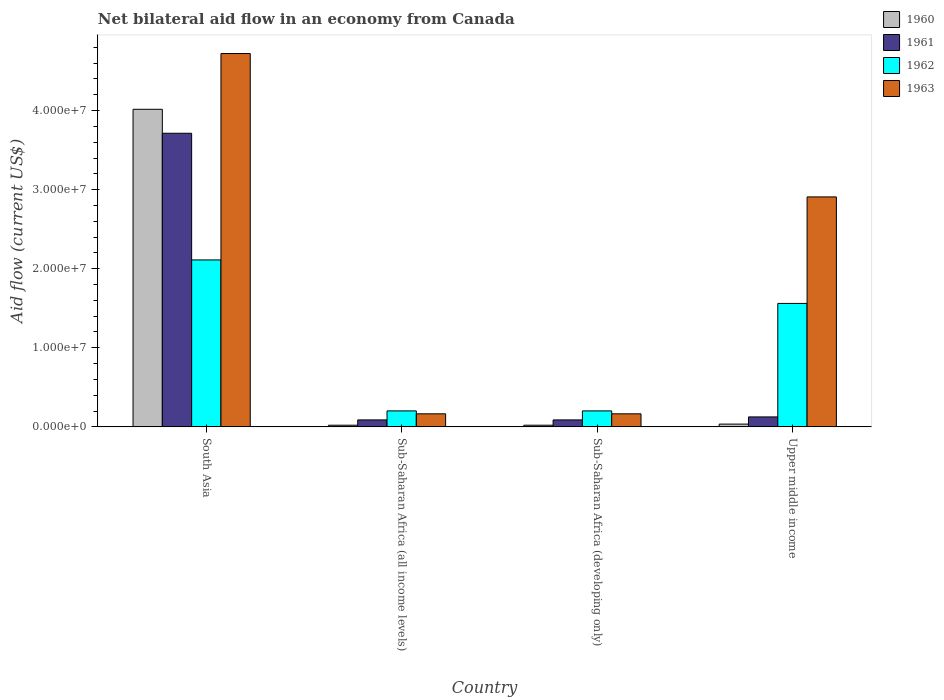How many different coloured bars are there?
Your answer should be very brief. 4. How many groups of bars are there?
Keep it short and to the point. 4. Are the number of bars on each tick of the X-axis equal?
Provide a short and direct response. Yes. How many bars are there on the 2nd tick from the right?
Provide a succinct answer. 4. What is the label of the 1st group of bars from the left?
Provide a succinct answer. South Asia. What is the net bilateral aid flow in 1962 in South Asia?
Your response must be concise. 2.11e+07. Across all countries, what is the maximum net bilateral aid flow in 1961?
Give a very brief answer. 3.71e+07. Across all countries, what is the minimum net bilateral aid flow in 1961?
Make the answer very short. 8.80e+05. In which country was the net bilateral aid flow in 1960 maximum?
Make the answer very short. South Asia. In which country was the net bilateral aid flow in 1962 minimum?
Offer a terse response. Sub-Saharan Africa (all income levels). What is the total net bilateral aid flow in 1963 in the graph?
Your answer should be very brief. 7.96e+07. What is the difference between the net bilateral aid flow in 1963 in Sub-Saharan Africa (developing only) and that in Upper middle income?
Provide a succinct answer. -2.74e+07. What is the difference between the net bilateral aid flow in 1961 in Sub-Saharan Africa (all income levels) and the net bilateral aid flow in 1962 in Sub-Saharan Africa (developing only)?
Provide a succinct answer. -1.14e+06. What is the average net bilateral aid flow in 1961 per country?
Make the answer very short. 1.00e+07. What is the difference between the net bilateral aid flow of/in 1963 and net bilateral aid flow of/in 1962 in Sub-Saharan Africa (developing only)?
Make the answer very short. -3.70e+05. What is the ratio of the net bilateral aid flow in 1963 in South Asia to that in Upper middle income?
Your answer should be compact. 1.62. Is the difference between the net bilateral aid flow in 1963 in Sub-Saharan Africa (developing only) and Upper middle income greater than the difference between the net bilateral aid flow in 1962 in Sub-Saharan Africa (developing only) and Upper middle income?
Offer a terse response. No. What is the difference between the highest and the second highest net bilateral aid flow in 1963?
Your answer should be very brief. 4.56e+07. What is the difference between the highest and the lowest net bilateral aid flow in 1963?
Provide a short and direct response. 4.56e+07. Is it the case that in every country, the sum of the net bilateral aid flow in 1962 and net bilateral aid flow in 1961 is greater than the sum of net bilateral aid flow in 1960 and net bilateral aid flow in 1963?
Make the answer very short. No. What does the 3rd bar from the left in South Asia represents?
Your answer should be very brief. 1962. What does the 4th bar from the right in Sub-Saharan Africa (all income levels) represents?
Your answer should be compact. 1960. Is it the case that in every country, the sum of the net bilateral aid flow in 1962 and net bilateral aid flow in 1963 is greater than the net bilateral aid flow in 1960?
Make the answer very short. Yes. How many bars are there?
Provide a succinct answer. 16. How many countries are there in the graph?
Your answer should be very brief. 4. What is the difference between two consecutive major ticks on the Y-axis?
Your response must be concise. 1.00e+07. Are the values on the major ticks of Y-axis written in scientific E-notation?
Your answer should be compact. Yes. Does the graph contain any zero values?
Offer a terse response. No. How are the legend labels stacked?
Ensure brevity in your answer.  Vertical. What is the title of the graph?
Your response must be concise. Net bilateral aid flow in an economy from Canada. Does "1978" appear as one of the legend labels in the graph?
Give a very brief answer. No. What is the label or title of the X-axis?
Provide a short and direct response. Country. What is the label or title of the Y-axis?
Give a very brief answer. Aid flow (current US$). What is the Aid flow (current US$) of 1960 in South Asia?
Your answer should be compact. 4.02e+07. What is the Aid flow (current US$) in 1961 in South Asia?
Provide a succinct answer. 3.71e+07. What is the Aid flow (current US$) in 1962 in South Asia?
Provide a short and direct response. 2.11e+07. What is the Aid flow (current US$) in 1963 in South Asia?
Ensure brevity in your answer.  4.72e+07. What is the Aid flow (current US$) in 1961 in Sub-Saharan Africa (all income levels)?
Make the answer very short. 8.80e+05. What is the Aid flow (current US$) in 1962 in Sub-Saharan Africa (all income levels)?
Your answer should be very brief. 2.02e+06. What is the Aid flow (current US$) in 1963 in Sub-Saharan Africa (all income levels)?
Provide a short and direct response. 1.65e+06. What is the Aid flow (current US$) in 1960 in Sub-Saharan Africa (developing only)?
Your answer should be very brief. 2.10e+05. What is the Aid flow (current US$) of 1961 in Sub-Saharan Africa (developing only)?
Offer a very short reply. 8.80e+05. What is the Aid flow (current US$) of 1962 in Sub-Saharan Africa (developing only)?
Your answer should be compact. 2.02e+06. What is the Aid flow (current US$) of 1963 in Sub-Saharan Africa (developing only)?
Offer a very short reply. 1.65e+06. What is the Aid flow (current US$) of 1960 in Upper middle income?
Your answer should be compact. 3.50e+05. What is the Aid flow (current US$) of 1961 in Upper middle income?
Make the answer very short. 1.26e+06. What is the Aid flow (current US$) of 1962 in Upper middle income?
Your response must be concise. 1.56e+07. What is the Aid flow (current US$) in 1963 in Upper middle income?
Your response must be concise. 2.91e+07. Across all countries, what is the maximum Aid flow (current US$) of 1960?
Make the answer very short. 4.02e+07. Across all countries, what is the maximum Aid flow (current US$) of 1961?
Keep it short and to the point. 3.71e+07. Across all countries, what is the maximum Aid flow (current US$) in 1962?
Keep it short and to the point. 2.11e+07. Across all countries, what is the maximum Aid flow (current US$) of 1963?
Offer a terse response. 4.72e+07. Across all countries, what is the minimum Aid flow (current US$) of 1961?
Your response must be concise. 8.80e+05. Across all countries, what is the minimum Aid flow (current US$) in 1962?
Your answer should be very brief. 2.02e+06. Across all countries, what is the minimum Aid flow (current US$) in 1963?
Offer a very short reply. 1.65e+06. What is the total Aid flow (current US$) in 1960 in the graph?
Make the answer very short. 4.09e+07. What is the total Aid flow (current US$) of 1961 in the graph?
Ensure brevity in your answer.  4.02e+07. What is the total Aid flow (current US$) of 1962 in the graph?
Keep it short and to the point. 4.08e+07. What is the total Aid flow (current US$) of 1963 in the graph?
Your response must be concise. 7.96e+07. What is the difference between the Aid flow (current US$) in 1960 in South Asia and that in Sub-Saharan Africa (all income levels)?
Your response must be concise. 4.00e+07. What is the difference between the Aid flow (current US$) of 1961 in South Asia and that in Sub-Saharan Africa (all income levels)?
Your answer should be very brief. 3.62e+07. What is the difference between the Aid flow (current US$) of 1962 in South Asia and that in Sub-Saharan Africa (all income levels)?
Your response must be concise. 1.91e+07. What is the difference between the Aid flow (current US$) in 1963 in South Asia and that in Sub-Saharan Africa (all income levels)?
Your answer should be very brief. 4.56e+07. What is the difference between the Aid flow (current US$) of 1960 in South Asia and that in Sub-Saharan Africa (developing only)?
Offer a terse response. 4.00e+07. What is the difference between the Aid flow (current US$) of 1961 in South Asia and that in Sub-Saharan Africa (developing only)?
Keep it short and to the point. 3.62e+07. What is the difference between the Aid flow (current US$) in 1962 in South Asia and that in Sub-Saharan Africa (developing only)?
Offer a terse response. 1.91e+07. What is the difference between the Aid flow (current US$) of 1963 in South Asia and that in Sub-Saharan Africa (developing only)?
Your answer should be very brief. 4.56e+07. What is the difference between the Aid flow (current US$) in 1960 in South Asia and that in Upper middle income?
Make the answer very short. 3.98e+07. What is the difference between the Aid flow (current US$) in 1961 in South Asia and that in Upper middle income?
Provide a short and direct response. 3.59e+07. What is the difference between the Aid flow (current US$) of 1962 in South Asia and that in Upper middle income?
Give a very brief answer. 5.50e+06. What is the difference between the Aid flow (current US$) of 1963 in South Asia and that in Upper middle income?
Make the answer very short. 1.81e+07. What is the difference between the Aid flow (current US$) of 1962 in Sub-Saharan Africa (all income levels) and that in Sub-Saharan Africa (developing only)?
Keep it short and to the point. 0. What is the difference between the Aid flow (current US$) in 1963 in Sub-Saharan Africa (all income levels) and that in Sub-Saharan Africa (developing only)?
Your answer should be very brief. 0. What is the difference between the Aid flow (current US$) of 1961 in Sub-Saharan Africa (all income levels) and that in Upper middle income?
Offer a very short reply. -3.80e+05. What is the difference between the Aid flow (current US$) of 1962 in Sub-Saharan Africa (all income levels) and that in Upper middle income?
Offer a terse response. -1.36e+07. What is the difference between the Aid flow (current US$) in 1963 in Sub-Saharan Africa (all income levels) and that in Upper middle income?
Keep it short and to the point. -2.74e+07. What is the difference between the Aid flow (current US$) in 1961 in Sub-Saharan Africa (developing only) and that in Upper middle income?
Keep it short and to the point. -3.80e+05. What is the difference between the Aid flow (current US$) in 1962 in Sub-Saharan Africa (developing only) and that in Upper middle income?
Make the answer very short. -1.36e+07. What is the difference between the Aid flow (current US$) in 1963 in Sub-Saharan Africa (developing only) and that in Upper middle income?
Ensure brevity in your answer.  -2.74e+07. What is the difference between the Aid flow (current US$) in 1960 in South Asia and the Aid flow (current US$) in 1961 in Sub-Saharan Africa (all income levels)?
Provide a short and direct response. 3.93e+07. What is the difference between the Aid flow (current US$) of 1960 in South Asia and the Aid flow (current US$) of 1962 in Sub-Saharan Africa (all income levels)?
Offer a very short reply. 3.81e+07. What is the difference between the Aid flow (current US$) of 1960 in South Asia and the Aid flow (current US$) of 1963 in Sub-Saharan Africa (all income levels)?
Provide a short and direct response. 3.85e+07. What is the difference between the Aid flow (current US$) in 1961 in South Asia and the Aid flow (current US$) in 1962 in Sub-Saharan Africa (all income levels)?
Your answer should be compact. 3.51e+07. What is the difference between the Aid flow (current US$) of 1961 in South Asia and the Aid flow (current US$) of 1963 in Sub-Saharan Africa (all income levels)?
Provide a succinct answer. 3.55e+07. What is the difference between the Aid flow (current US$) in 1962 in South Asia and the Aid flow (current US$) in 1963 in Sub-Saharan Africa (all income levels)?
Provide a succinct answer. 1.95e+07. What is the difference between the Aid flow (current US$) in 1960 in South Asia and the Aid flow (current US$) in 1961 in Sub-Saharan Africa (developing only)?
Your answer should be very brief. 3.93e+07. What is the difference between the Aid flow (current US$) in 1960 in South Asia and the Aid flow (current US$) in 1962 in Sub-Saharan Africa (developing only)?
Ensure brevity in your answer.  3.81e+07. What is the difference between the Aid flow (current US$) of 1960 in South Asia and the Aid flow (current US$) of 1963 in Sub-Saharan Africa (developing only)?
Your answer should be compact. 3.85e+07. What is the difference between the Aid flow (current US$) of 1961 in South Asia and the Aid flow (current US$) of 1962 in Sub-Saharan Africa (developing only)?
Make the answer very short. 3.51e+07. What is the difference between the Aid flow (current US$) of 1961 in South Asia and the Aid flow (current US$) of 1963 in Sub-Saharan Africa (developing only)?
Your response must be concise. 3.55e+07. What is the difference between the Aid flow (current US$) of 1962 in South Asia and the Aid flow (current US$) of 1963 in Sub-Saharan Africa (developing only)?
Keep it short and to the point. 1.95e+07. What is the difference between the Aid flow (current US$) of 1960 in South Asia and the Aid flow (current US$) of 1961 in Upper middle income?
Your answer should be very brief. 3.89e+07. What is the difference between the Aid flow (current US$) in 1960 in South Asia and the Aid flow (current US$) in 1962 in Upper middle income?
Offer a terse response. 2.46e+07. What is the difference between the Aid flow (current US$) in 1960 in South Asia and the Aid flow (current US$) in 1963 in Upper middle income?
Provide a succinct answer. 1.11e+07. What is the difference between the Aid flow (current US$) of 1961 in South Asia and the Aid flow (current US$) of 1962 in Upper middle income?
Make the answer very short. 2.15e+07. What is the difference between the Aid flow (current US$) of 1961 in South Asia and the Aid flow (current US$) of 1963 in Upper middle income?
Give a very brief answer. 8.05e+06. What is the difference between the Aid flow (current US$) in 1962 in South Asia and the Aid flow (current US$) in 1963 in Upper middle income?
Your answer should be compact. -7.97e+06. What is the difference between the Aid flow (current US$) of 1960 in Sub-Saharan Africa (all income levels) and the Aid flow (current US$) of 1961 in Sub-Saharan Africa (developing only)?
Provide a succinct answer. -6.70e+05. What is the difference between the Aid flow (current US$) of 1960 in Sub-Saharan Africa (all income levels) and the Aid flow (current US$) of 1962 in Sub-Saharan Africa (developing only)?
Ensure brevity in your answer.  -1.81e+06. What is the difference between the Aid flow (current US$) of 1960 in Sub-Saharan Africa (all income levels) and the Aid flow (current US$) of 1963 in Sub-Saharan Africa (developing only)?
Your response must be concise. -1.44e+06. What is the difference between the Aid flow (current US$) of 1961 in Sub-Saharan Africa (all income levels) and the Aid flow (current US$) of 1962 in Sub-Saharan Africa (developing only)?
Your answer should be very brief. -1.14e+06. What is the difference between the Aid flow (current US$) in 1961 in Sub-Saharan Africa (all income levels) and the Aid flow (current US$) in 1963 in Sub-Saharan Africa (developing only)?
Offer a terse response. -7.70e+05. What is the difference between the Aid flow (current US$) of 1962 in Sub-Saharan Africa (all income levels) and the Aid flow (current US$) of 1963 in Sub-Saharan Africa (developing only)?
Your answer should be very brief. 3.70e+05. What is the difference between the Aid flow (current US$) of 1960 in Sub-Saharan Africa (all income levels) and the Aid flow (current US$) of 1961 in Upper middle income?
Make the answer very short. -1.05e+06. What is the difference between the Aid flow (current US$) in 1960 in Sub-Saharan Africa (all income levels) and the Aid flow (current US$) in 1962 in Upper middle income?
Your response must be concise. -1.54e+07. What is the difference between the Aid flow (current US$) of 1960 in Sub-Saharan Africa (all income levels) and the Aid flow (current US$) of 1963 in Upper middle income?
Offer a very short reply. -2.89e+07. What is the difference between the Aid flow (current US$) in 1961 in Sub-Saharan Africa (all income levels) and the Aid flow (current US$) in 1962 in Upper middle income?
Keep it short and to the point. -1.47e+07. What is the difference between the Aid flow (current US$) in 1961 in Sub-Saharan Africa (all income levels) and the Aid flow (current US$) in 1963 in Upper middle income?
Offer a terse response. -2.82e+07. What is the difference between the Aid flow (current US$) in 1962 in Sub-Saharan Africa (all income levels) and the Aid flow (current US$) in 1963 in Upper middle income?
Offer a terse response. -2.71e+07. What is the difference between the Aid flow (current US$) in 1960 in Sub-Saharan Africa (developing only) and the Aid flow (current US$) in 1961 in Upper middle income?
Your answer should be very brief. -1.05e+06. What is the difference between the Aid flow (current US$) in 1960 in Sub-Saharan Africa (developing only) and the Aid flow (current US$) in 1962 in Upper middle income?
Make the answer very short. -1.54e+07. What is the difference between the Aid flow (current US$) in 1960 in Sub-Saharan Africa (developing only) and the Aid flow (current US$) in 1963 in Upper middle income?
Ensure brevity in your answer.  -2.89e+07. What is the difference between the Aid flow (current US$) of 1961 in Sub-Saharan Africa (developing only) and the Aid flow (current US$) of 1962 in Upper middle income?
Give a very brief answer. -1.47e+07. What is the difference between the Aid flow (current US$) of 1961 in Sub-Saharan Africa (developing only) and the Aid flow (current US$) of 1963 in Upper middle income?
Provide a succinct answer. -2.82e+07. What is the difference between the Aid flow (current US$) in 1962 in Sub-Saharan Africa (developing only) and the Aid flow (current US$) in 1963 in Upper middle income?
Ensure brevity in your answer.  -2.71e+07. What is the average Aid flow (current US$) of 1960 per country?
Offer a terse response. 1.02e+07. What is the average Aid flow (current US$) in 1961 per country?
Provide a short and direct response. 1.00e+07. What is the average Aid flow (current US$) in 1962 per country?
Keep it short and to the point. 1.02e+07. What is the average Aid flow (current US$) of 1963 per country?
Offer a terse response. 1.99e+07. What is the difference between the Aid flow (current US$) in 1960 and Aid flow (current US$) in 1961 in South Asia?
Keep it short and to the point. 3.03e+06. What is the difference between the Aid flow (current US$) of 1960 and Aid flow (current US$) of 1962 in South Asia?
Offer a terse response. 1.90e+07. What is the difference between the Aid flow (current US$) of 1960 and Aid flow (current US$) of 1963 in South Asia?
Give a very brief answer. -7.05e+06. What is the difference between the Aid flow (current US$) in 1961 and Aid flow (current US$) in 1962 in South Asia?
Your answer should be compact. 1.60e+07. What is the difference between the Aid flow (current US$) of 1961 and Aid flow (current US$) of 1963 in South Asia?
Provide a short and direct response. -1.01e+07. What is the difference between the Aid flow (current US$) in 1962 and Aid flow (current US$) in 1963 in South Asia?
Provide a succinct answer. -2.61e+07. What is the difference between the Aid flow (current US$) of 1960 and Aid flow (current US$) of 1961 in Sub-Saharan Africa (all income levels)?
Provide a succinct answer. -6.70e+05. What is the difference between the Aid flow (current US$) of 1960 and Aid flow (current US$) of 1962 in Sub-Saharan Africa (all income levels)?
Your answer should be compact. -1.81e+06. What is the difference between the Aid flow (current US$) of 1960 and Aid flow (current US$) of 1963 in Sub-Saharan Africa (all income levels)?
Your answer should be very brief. -1.44e+06. What is the difference between the Aid flow (current US$) of 1961 and Aid flow (current US$) of 1962 in Sub-Saharan Africa (all income levels)?
Offer a very short reply. -1.14e+06. What is the difference between the Aid flow (current US$) of 1961 and Aid flow (current US$) of 1963 in Sub-Saharan Africa (all income levels)?
Provide a short and direct response. -7.70e+05. What is the difference between the Aid flow (current US$) in 1960 and Aid flow (current US$) in 1961 in Sub-Saharan Africa (developing only)?
Give a very brief answer. -6.70e+05. What is the difference between the Aid flow (current US$) of 1960 and Aid flow (current US$) of 1962 in Sub-Saharan Africa (developing only)?
Your response must be concise. -1.81e+06. What is the difference between the Aid flow (current US$) in 1960 and Aid flow (current US$) in 1963 in Sub-Saharan Africa (developing only)?
Your response must be concise. -1.44e+06. What is the difference between the Aid flow (current US$) of 1961 and Aid flow (current US$) of 1962 in Sub-Saharan Africa (developing only)?
Keep it short and to the point. -1.14e+06. What is the difference between the Aid flow (current US$) in 1961 and Aid flow (current US$) in 1963 in Sub-Saharan Africa (developing only)?
Your answer should be very brief. -7.70e+05. What is the difference between the Aid flow (current US$) of 1960 and Aid flow (current US$) of 1961 in Upper middle income?
Your answer should be compact. -9.10e+05. What is the difference between the Aid flow (current US$) of 1960 and Aid flow (current US$) of 1962 in Upper middle income?
Your response must be concise. -1.53e+07. What is the difference between the Aid flow (current US$) of 1960 and Aid flow (current US$) of 1963 in Upper middle income?
Give a very brief answer. -2.87e+07. What is the difference between the Aid flow (current US$) of 1961 and Aid flow (current US$) of 1962 in Upper middle income?
Give a very brief answer. -1.44e+07. What is the difference between the Aid flow (current US$) of 1961 and Aid flow (current US$) of 1963 in Upper middle income?
Your answer should be very brief. -2.78e+07. What is the difference between the Aid flow (current US$) in 1962 and Aid flow (current US$) in 1963 in Upper middle income?
Provide a short and direct response. -1.35e+07. What is the ratio of the Aid flow (current US$) in 1960 in South Asia to that in Sub-Saharan Africa (all income levels)?
Ensure brevity in your answer.  191.24. What is the ratio of the Aid flow (current US$) of 1961 in South Asia to that in Sub-Saharan Africa (all income levels)?
Your answer should be compact. 42.19. What is the ratio of the Aid flow (current US$) of 1962 in South Asia to that in Sub-Saharan Africa (all income levels)?
Your answer should be compact. 10.45. What is the ratio of the Aid flow (current US$) of 1963 in South Asia to that in Sub-Saharan Africa (all income levels)?
Your answer should be very brief. 28.61. What is the ratio of the Aid flow (current US$) in 1960 in South Asia to that in Sub-Saharan Africa (developing only)?
Your response must be concise. 191.24. What is the ratio of the Aid flow (current US$) of 1961 in South Asia to that in Sub-Saharan Africa (developing only)?
Your answer should be compact. 42.19. What is the ratio of the Aid flow (current US$) in 1962 in South Asia to that in Sub-Saharan Africa (developing only)?
Make the answer very short. 10.45. What is the ratio of the Aid flow (current US$) in 1963 in South Asia to that in Sub-Saharan Africa (developing only)?
Your response must be concise. 28.61. What is the ratio of the Aid flow (current US$) in 1960 in South Asia to that in Upper middle income?
Your answer should be very brief. 114.74. What is the ratio of the Aid flow (current US$) of 1961 in South Asia to that in Upper middle income?
Give a very brief answer. 29.47. What is the ratio of the Aid flow (current US$) of 1962 in South Asia to that in Upper middle income?
Provide a succinct answer. 1.35. What is the ratio of the Aid flow (current US$) in 1963 in South Asia to that in Upper middle income?
Offer a terse response. 1.62. What is the ratio of the Aid flow (current US$) of 1960 in Sub-Saharan Africa (all income levels) to that in Sub-Saharan Africa (developing only)?
Provide a succinct answer. 1. What is the ratio of the Aid flow (current US$) in 1961 in Sub-Saharan Africa (all income levels) to that in Sub-Saharan Africa (developing only)?
Provide a succinct answer. 1. What is the ratio of the Aid flow (current US$) in 1962 in Sub-Saharan Africa (all income levels) to that in Sub-Saharan Africa (developing only)?
Provide a short and direct response. 1. What is the ratio of the Aid flow (current US$) of 1961 in Sub-Saharan Africa (all income levels) to that in Upper middle income?
Make the answer very short. 0.7. What is the ratio of the Aid flow (current US$) of 1962 in Sub-Saharan Africa (all income levels) to that in Upper middle income?
Make the answer very short. 0.13. What is the ratio of the Aid flow (current US$) in 1963 in Sub-Saharan Africa (all income levels) to that in Upper middle income?
Provide a short and direct response. 0.06. What is the ratio of the Aid flow (current US$) in 1960 in Sub-Saharan Africa (developing only) to that in Upper middle income?
Give a very brief answer. 0.6. What is the ratio of the Aid flow (current US$) of 1961 in Sub-Saharan Africa (developing only) to that in Upper middle income?
Offer a very short reply. 0.7. What is the ratio of the Aid flow (current US$) of 1962 in Sub-Saharan Africa (developing only) to that in Upper middle income?
Keep it short and to the point. 0.13. What is the ratio of the Aid flow (current US$) of 1963 in Sub-Saharan Africa (developing only) to that in Upper middle income?
Your response must be concise. 0.06. What is the difference between the highest and the second highest Aid flow (current US$) in 1960?
Offer a very short reply. 3.98e+07. What is the difference between the highest and the second highest Aid flow (current US$) of 1961?
Make the answer very short. 3.59e+07. What is the difference between the highest and the second highest Aid flow (current US$) in 1962?
Ensure brevity in your answer.  5.50e+06. What is the difference between the highest and the second highest Aid flow (current US$) of 1963?
Provide a succinct answer. 1.81e+07. What is the difference between the highest and the lowest Aid flow (current US$) of 1960?
Ensure brevity in your answer.  4.00e+07. What is the difference between the highest and the lowest Aid flow (current US$) of 1961?
Offer a terse response. 3.62e+07. What is the difference between the highest and the lowest Aid flow (current US$) of 1962?
Make the answer very short. 1.91e+07. What is the difference between the highest and the lowest Aid flow (current US$) in 1963?
Give a very brief answer. 4.56e+07. 